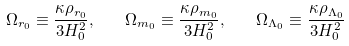Convert formula to latex. <formula><loc_0><loc_0><loc_500><loc_500>\Omega _ { r _ { 0 } } \equiv \frac { \kappa \rho _ { r _ { 0 } } } { 3 H _ { 0 } ^ { 2 } } , \quad \Omega _ { m _ { 0 } } \equiv \frac { \kappa \rho _ { m _ { 0 } } } { 3 H _ { 0 } ^ { 2 } } , \quad \Omega _ { \Lambda _ { 0 } } \equiv \frac { \kappa \rho _ { \Lambda _ { 0 } } } { 3 H _ { 0 } ^ { 2 } }</formula> 